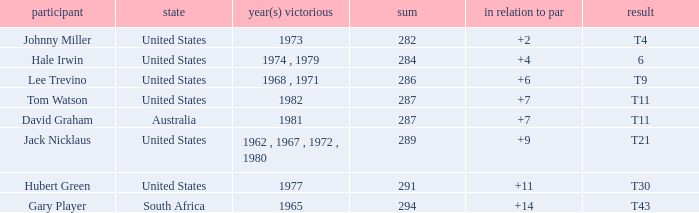WHAT IS THE TOTAL, OF A TO PAR FOR HUBERT GREEN, AND A TOTAL LARGER THAN 291? 0.0. 